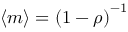<formula> <loc_0><loc_0><loc_500><loc_500>\langle m \rangle = { ( 1 - \rho ) } ^ { - 1 }</formula> 